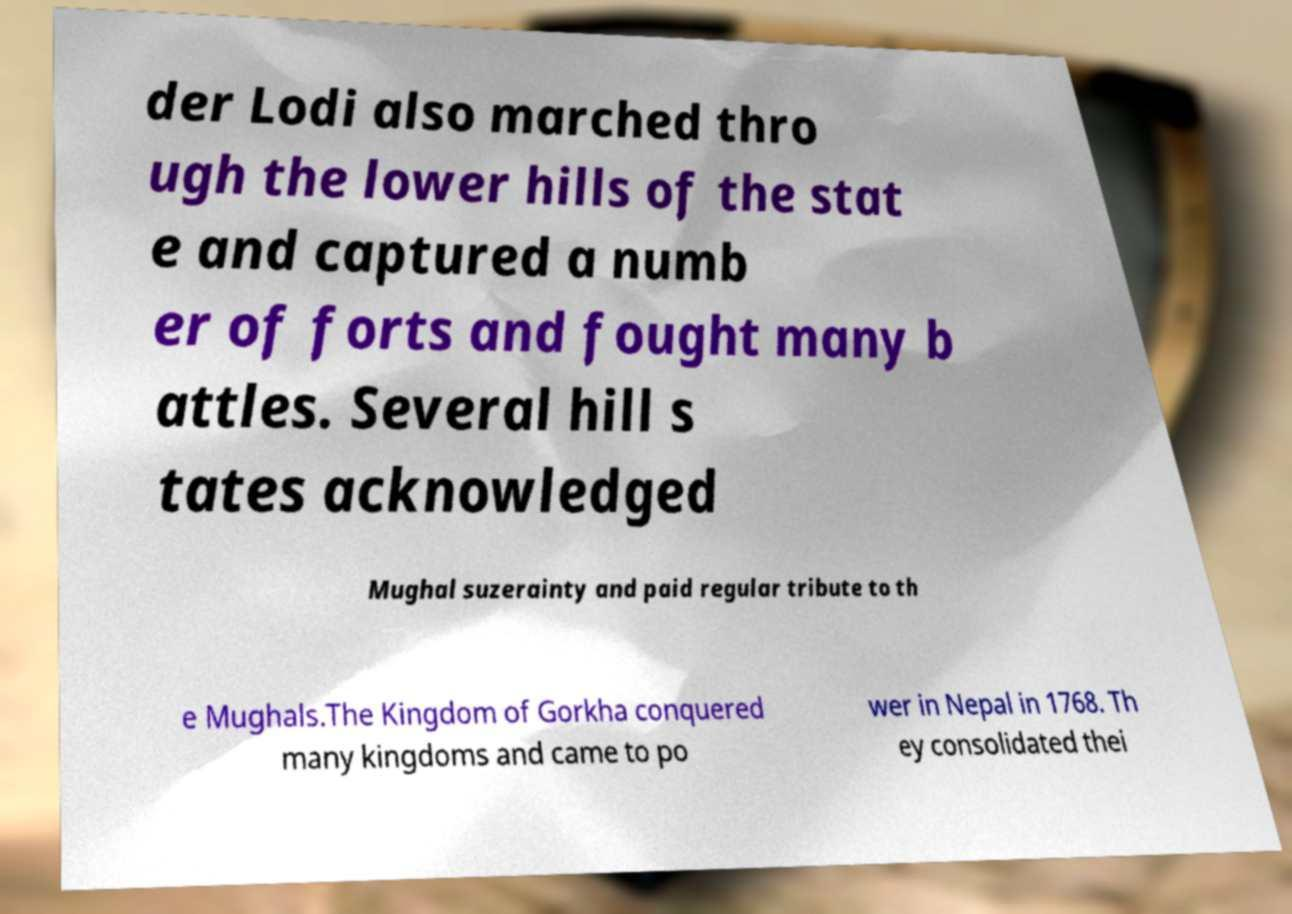For documentation purposes, I need the text within this image transcribed. Could you provide that? der Lodi also marched thro ugh the lower hills of the stat e and captured a numb er of forts and fought many b attles. Several hill s tates acknowledged Mughal suzerainty and paid regular tribute to th e Mughals.The Kingdom of Gorkha conquered many kingdoms and came to po wer in Nepal in 1768. Th ey consolidated thei 